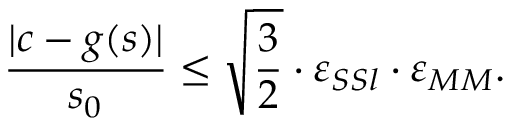Convert formula to latex. <formula><loc_0><loc_0><loc_500><loc_500>\frac { | c - g ( s ) | } { s _ { 0 } } \leq \sqrt { } { 3 } 2 \cdot \varepsilon _ { S S l } \cdot \varepsilon _ { M M } .</formula> 